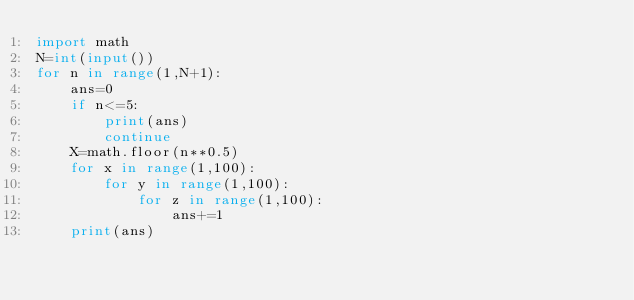Convert code to text. <code><loc_0><loc_0><loc_500><loc_500><_Python_>import math
N=int(input())
for n in range(1,N+1):
    ans=0
    if n<=5:
        print(ans)
        continue
    X=math.floor(n**0.5)
    for x in range(1,100):
        for y in range(1,100):
            for z in range(1,100):
                ans+=1
    print(ans)

</code> 